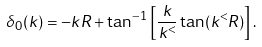<formula> <loc_0><loc_0><loc_500><loc_500>\delta _ { 0 } ( k ) = - k R + \tan ^ { - 1 } \left [ \frac { k } { k ^ { < } } \tan ( k ^ { < } R ) \right ] .</formula> 